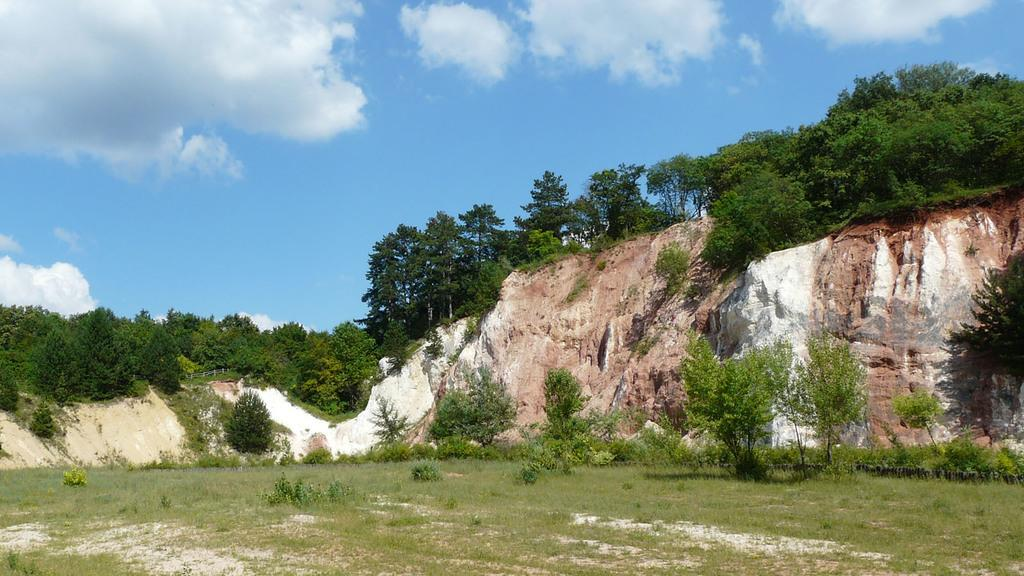What type of vegetation covers the land in the image? The land is covered with grass and small plants. What can be seen in the background of the image? There is a hill behind the grassy land. What type of vegetation is present on the hill? There are plenty of trees on the hill. What is the father's role in the image? There is no father present in the image, as it only features a landscape with grass, small plants, a hill, and trees. 